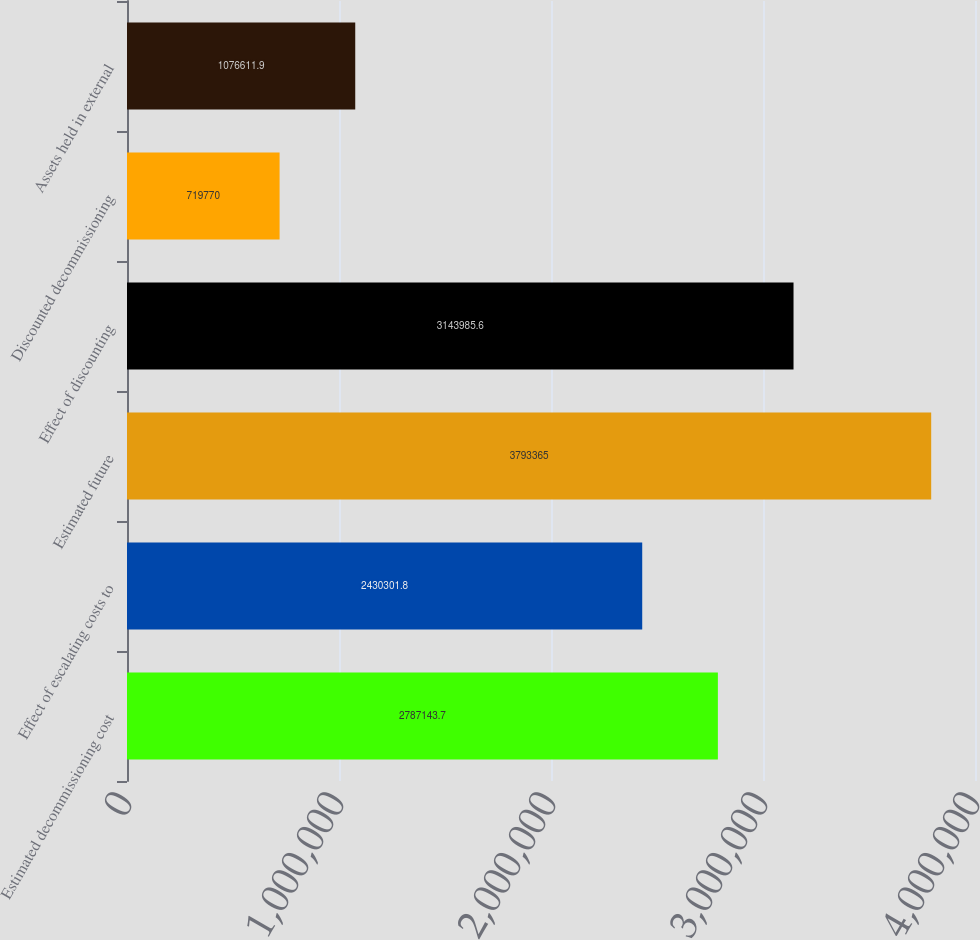Convert chart. <chart><loc_0><loc_0><loc_500><loc_500><bar_chart><fcel>Estimated decommissioning cost<fcel>Effect of escalating costs to<fcel>Estimated future<fcel>Effect of discounting<fcel>Discounted decommissioning<fcel>Assets held in external<nl><fcel>2.78714e+06<fcel>2.4303e+06<fcel>3.79336e+06<fcel>3.14399e+06<fcel>719770<fcel>1.07661e+06<nl></chart> 